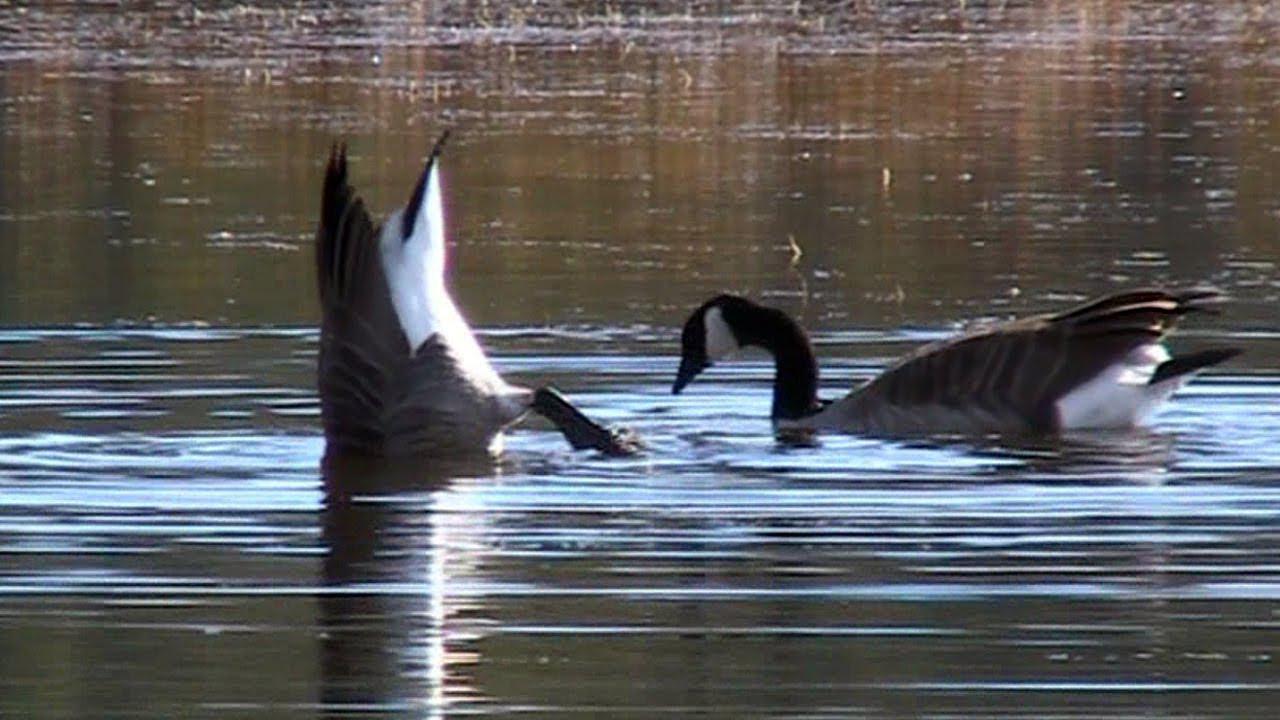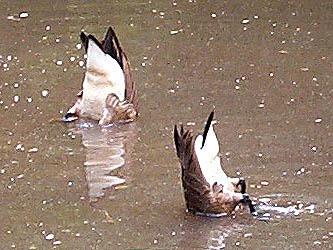The first image is the image on the left, the second image is the image on the right. Analyze the images presented: Is the assertion "there is a single goose with a knob on it's forehead" valid? Answer yes or no. No. The first image is the image on the left, the second image is the image on the right. Assess this claim about the two images: "A goose has a horn-like projection above its beak, and the only bird in the foreground of the image on the right is white.". Correct or not? Answer yes or no. No. 